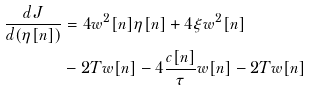Convert formula to latex. <formula><loc_0><loc_0><loc_500><loc_500>\frac { d J } { d ( \eta [ n ] ) } & = 4 w ^ { 2 } [ n ] \eta [ n ] + 4 \xi w ^ { 2 } [ n ] \\ & - 2 T w [ n ] - 4 \frac { c [ n ] } { \tau } w [ n ] - 2 T w [ n ]</formula> 